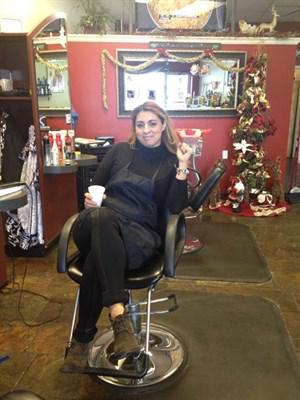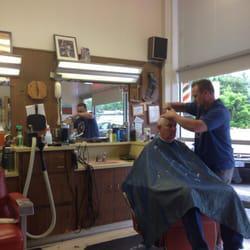The first image is the image on the left, the second image is the image on the right. For the images shown, is this caption "A woman is working on a man's hair in the left image." true? Answer yes or no. No. The first image is the image on the left, the second image is the image on the right. Considering the images on both sides, is "A woman works on a man's hair in the image on the left." valid? Answer yes or no. No. 